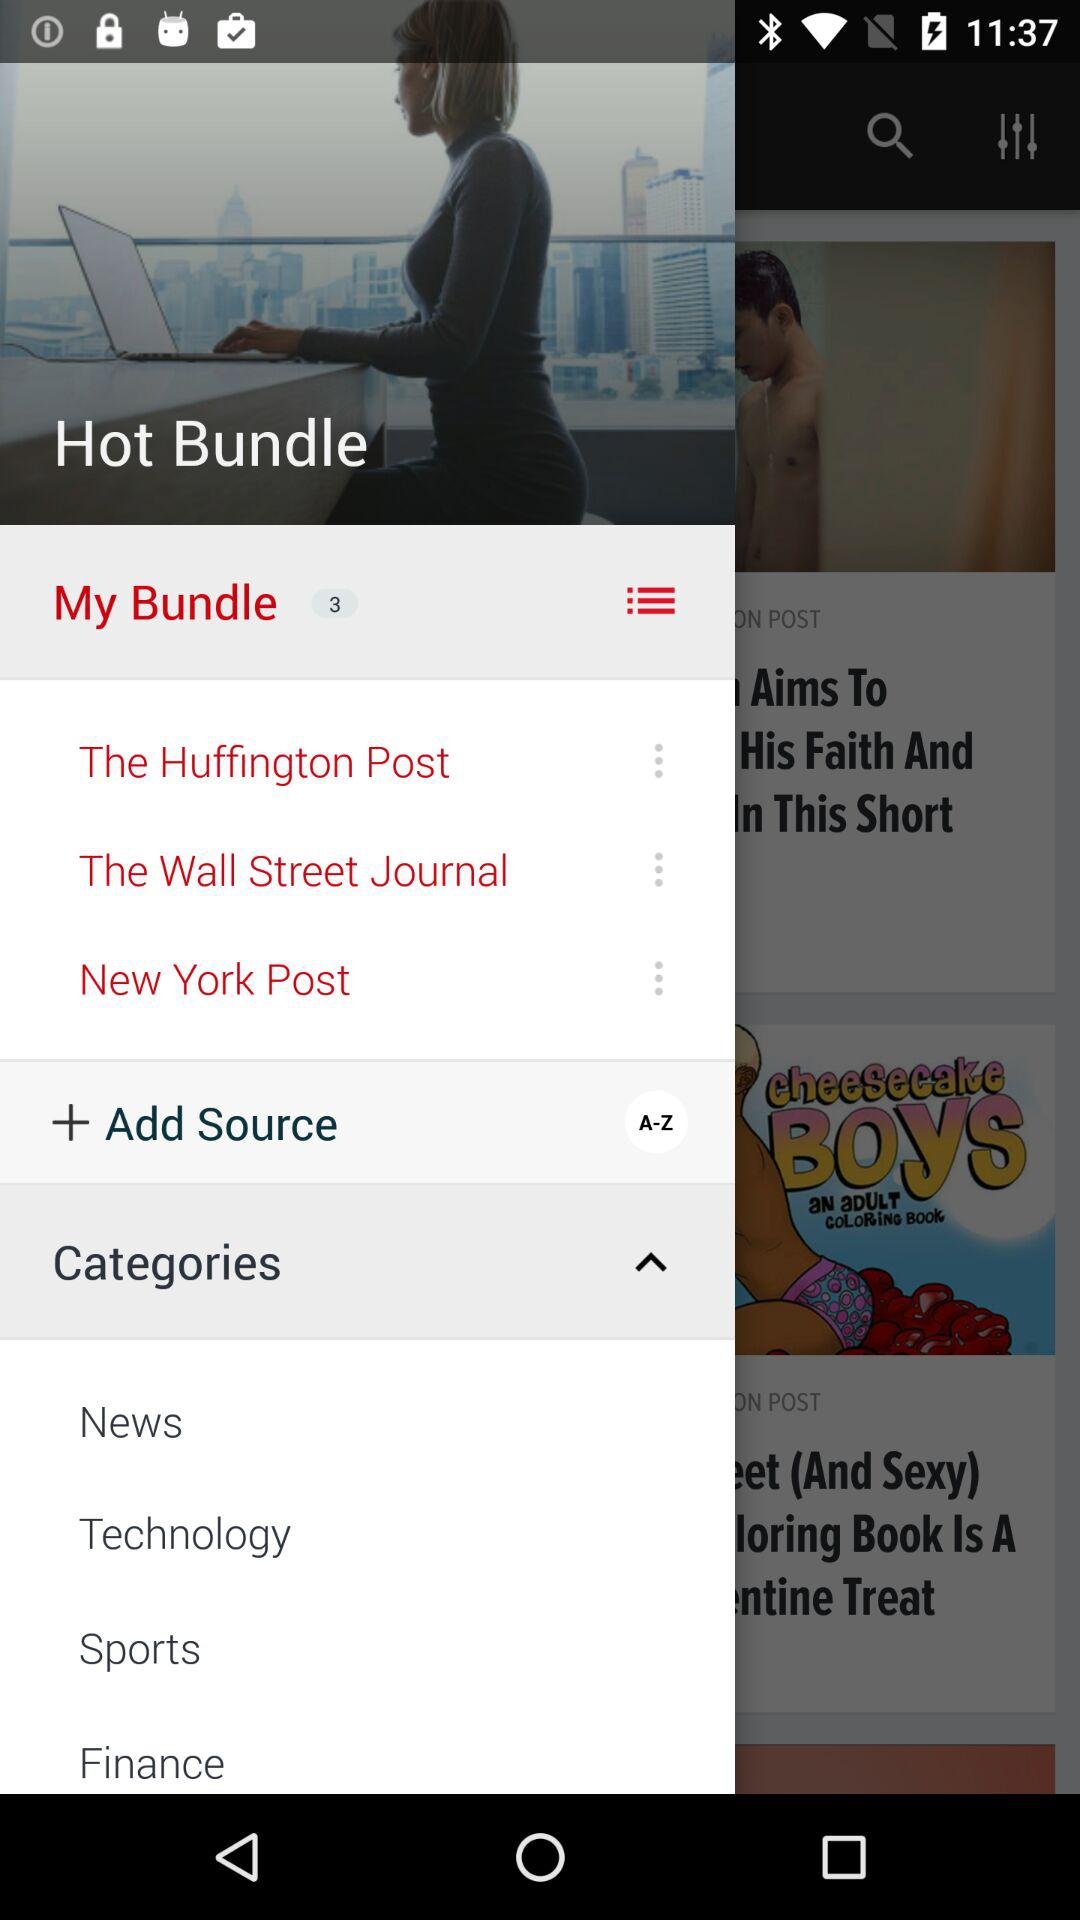What are the different categories shown on the screen? The different categories are news, technology, sports, and finance. 